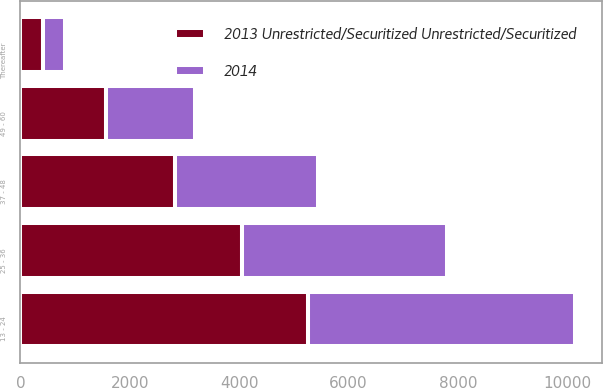Convert chart to OTSL. <chart><loc_0><loc_0><loc_500><loc_500><stacked_bar_chart><ecel><fcel>13 - 24<fcel>25 - 36<fcel>37 - 48<fcel>49 - 60<fcel>Thereafter<nl><fcel>2013 Unrestricted/Securitized Unrestricted/Securitized<fcel>5254<fcel>4053<fcel>2819<fcel>1575<fcel>414<nl><fcel>2014<fcel>4879<fcel>3750<fcel>2620<fcel>1610<fcel>396<nl></chart> 